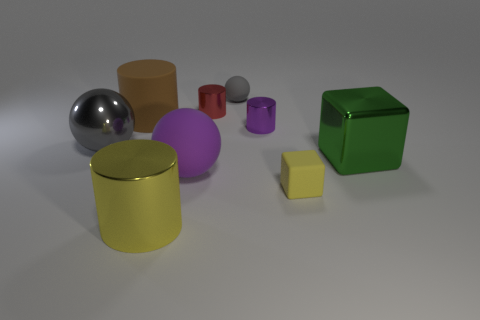Subtract all green cylinders. How many gray balls are left? 2 Subtract all brown matte cylinders. How many cylinders are left? 3 Subtract all yellow cylinders. How many cylinders are left? 3 Subtract all gray cylinders. Subtract all cyan spheres. How many cylinders are left? 4 Subtract all balls. How many objects are left? 6 Subtract all cubes. Subtract all large green cubes. How many objects are left? 6 Add 3 purple shiny objects. How many purple shiny objects are left? 4 Add 2 tiny gray rubber spheres. How many tiny gray rubber spheres exist? 3 Subtract 0 yellow balls. How many objects are left? 9 